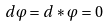Convert formula to latex. <formula><loc_0><loc_0><loc_500><loc_500>d \varphi = d \ast \varphi = 0</formula> 